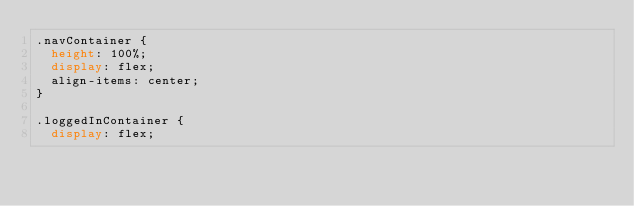<code> <loc_0><loc_0><loc_500><loc_500><_CSS_>.navContainer {
  height: 100%;
  display: flex;
  align-items: center;
}

.loggedInContainer {
  display: flex;</code> 